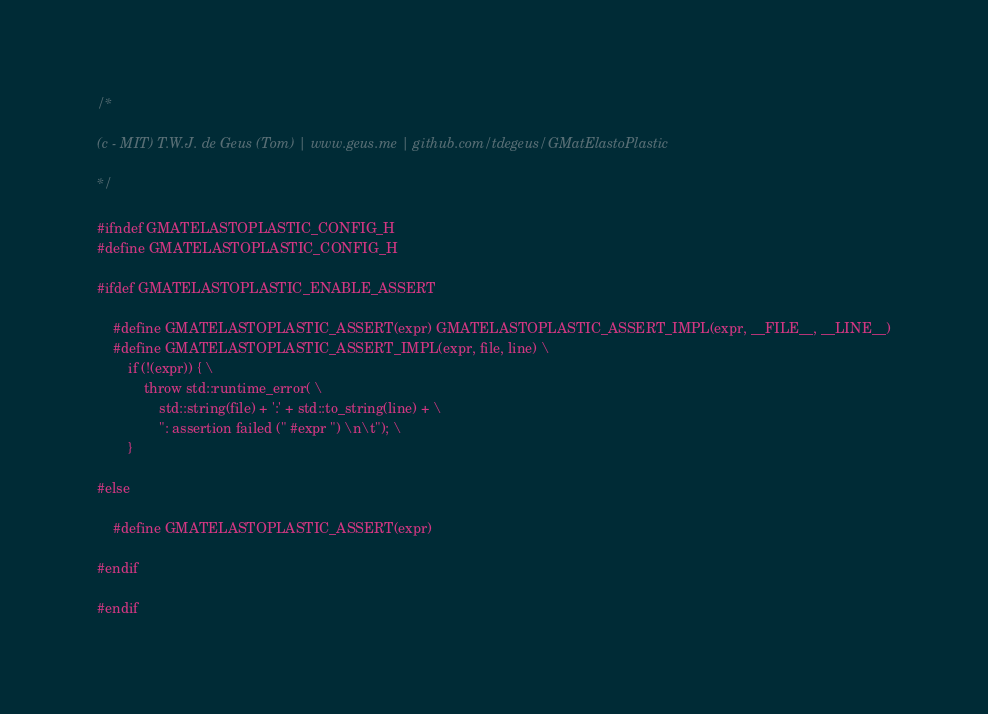Convert code to text. <code><loc_0><loc_0><loc_500><loc_500><_C_>/*

(c - MIT) T.W.J. de Geus (Tom) | www.geus.me | github.com/tdegeus/GMatElastoPlastic

*/

#ifndef GMATELASTOPLASTIC_CONFIG_H
#define GMATELASTOPLASTIC_CONFIG_H

#ifdef GMATELASTOPLASTIC_ENABLE_ASSERT

    #define GMATELASTOPLASTIC_ASSERT(expr) GMATELASTOPLASTIC_ASSERT_IMPL(expr, __FILE__, __LINE__)
    #define GMATELASTOPLASTIC_ASSERT_IMPL(expr, file, line) \
        if (!(expr)) { \
            throw std::runtime_error( \
                std::string(file) + ':' + std::to_string(line) + \
                ": assertion failed (" #expr ") \n\t"); \
        }

#else

    #define GMATELASTOPLASTIC_ASSERT(expr)

#endif

#endif
</code> 